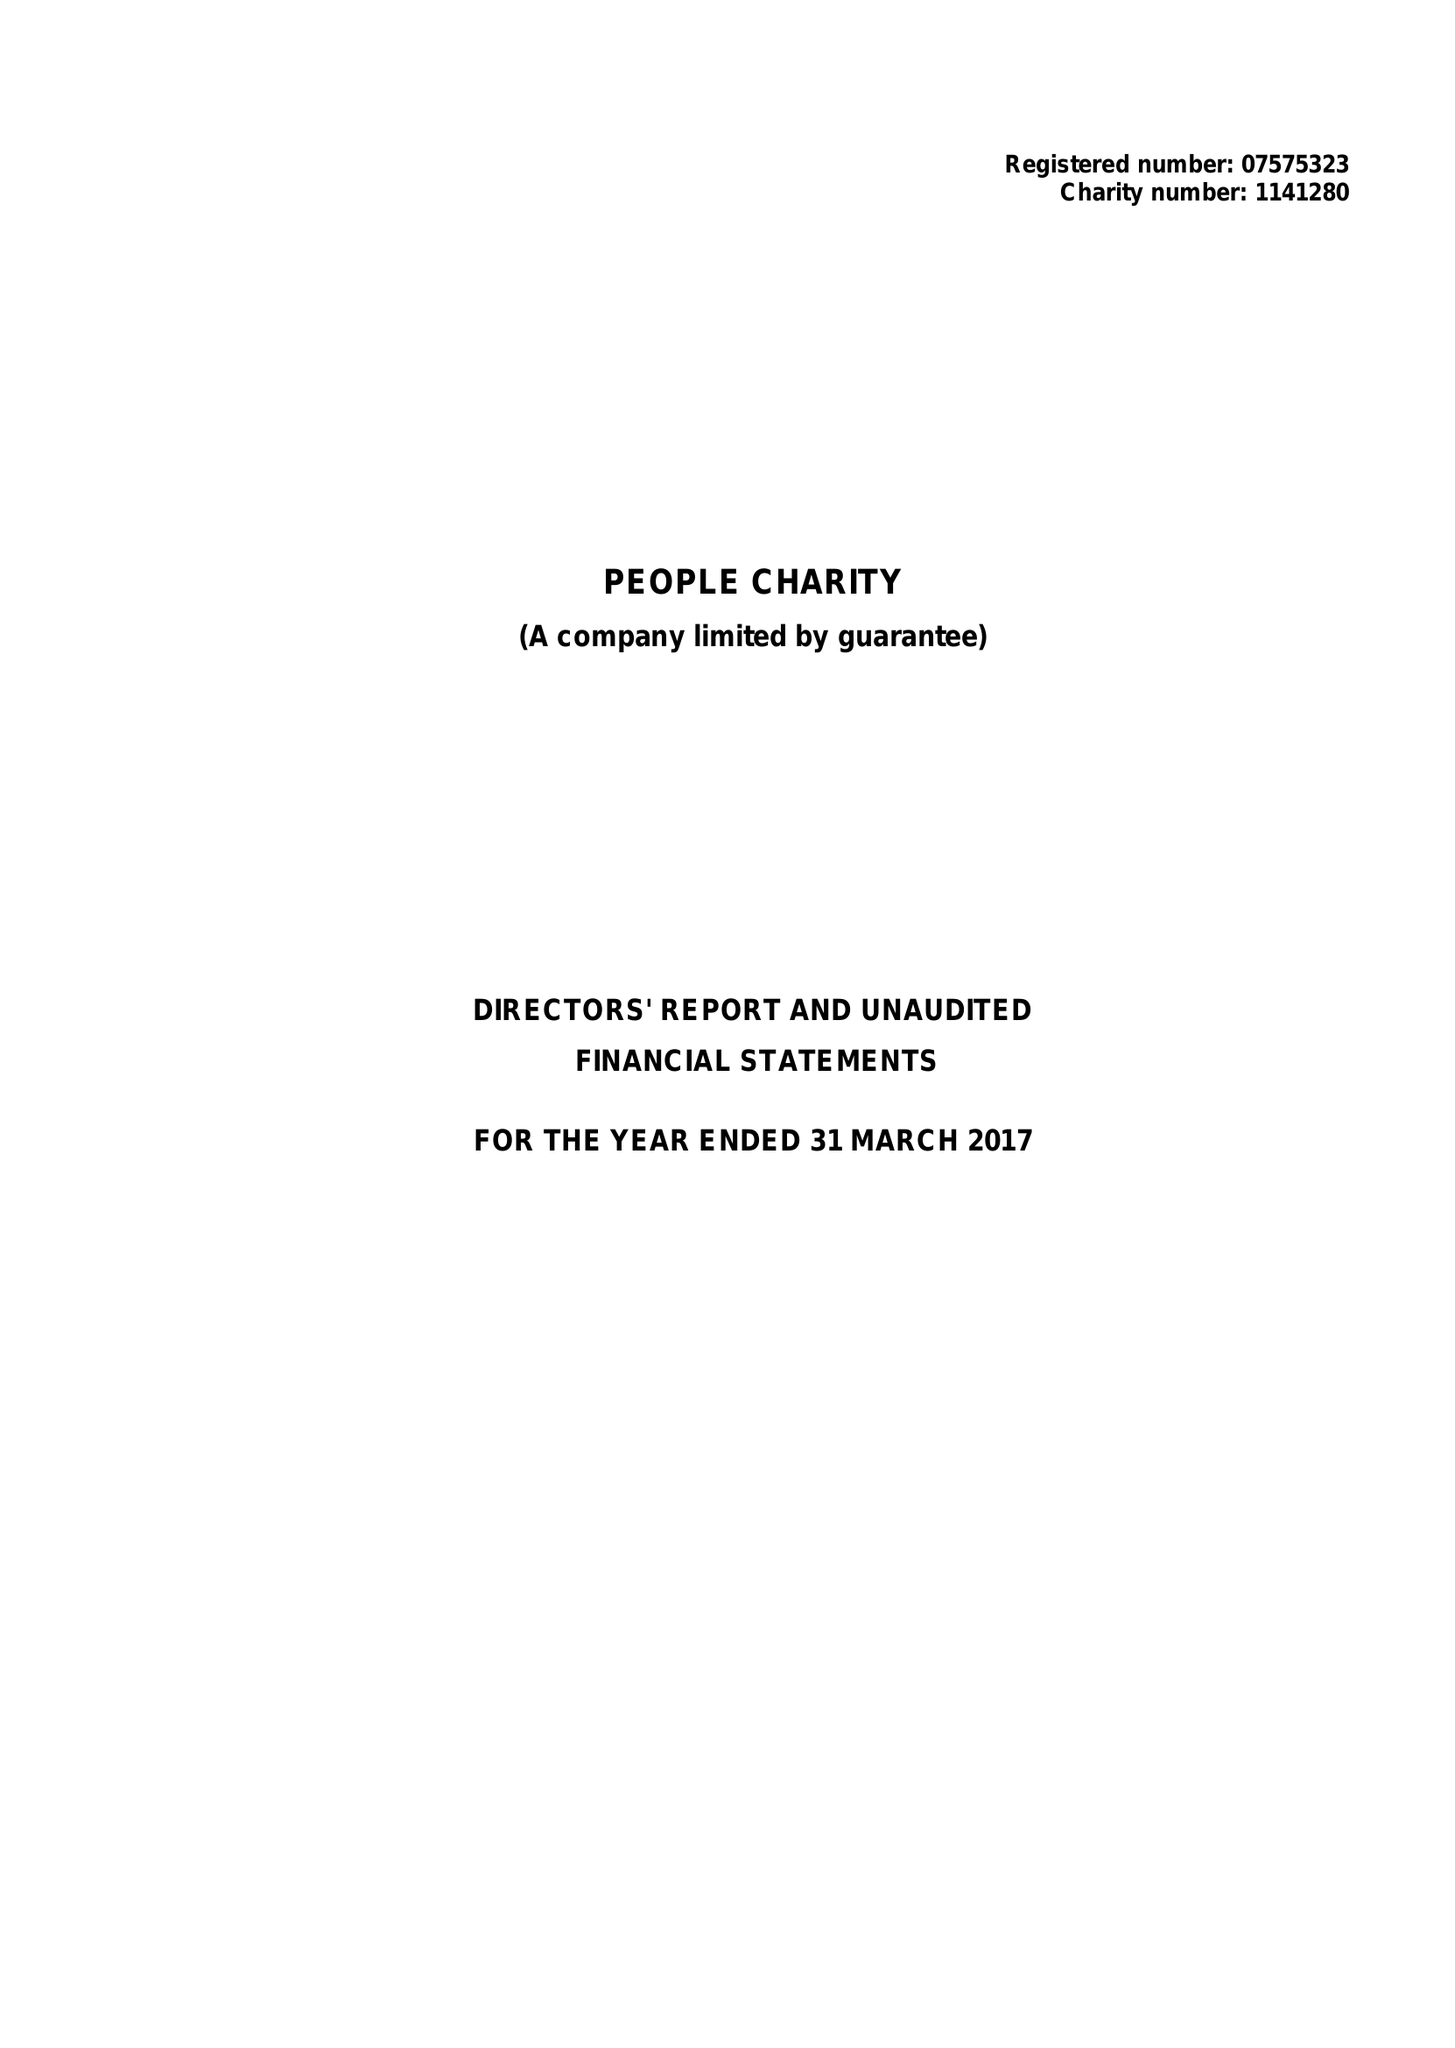What is the value for the address__postcode?
Answer the question using a single word or phrase. SE1 7QY 